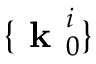<formula> <loc_0><loc_0><loc_500><loc_500>\{ k _ { 0 } ^ { i } \}</formula> 